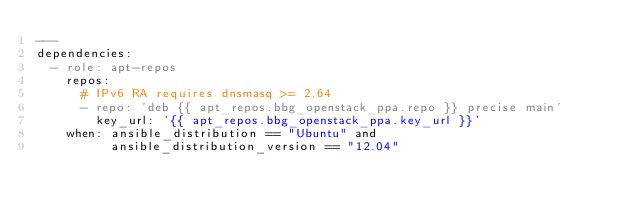Convert code to text. <code><loc_0><loc_0><loc_500><loc_500><_YAML_>---
dependencies:
  - role: apt-repos
    repos:
      # IPv6 RA requires dnsmasq >= 2.64
      - repo: 'deb {{ apt_repos.bbg_openstack_ppa.repo }} precise main'
        key_url: '{{ apt_repos.bbg_openstack_ppa.key_url }}'
    when: ansible_distribution == "Ubuntu" and
          ansible_distribution_version == "12.04"
</code> 